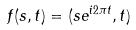Convert formula to latex. <formula><loc_0><loc_0><loc_500><loc_500>f ( s , t ) = ( s e ^ { i 2 \pi t } , t )</formula> 